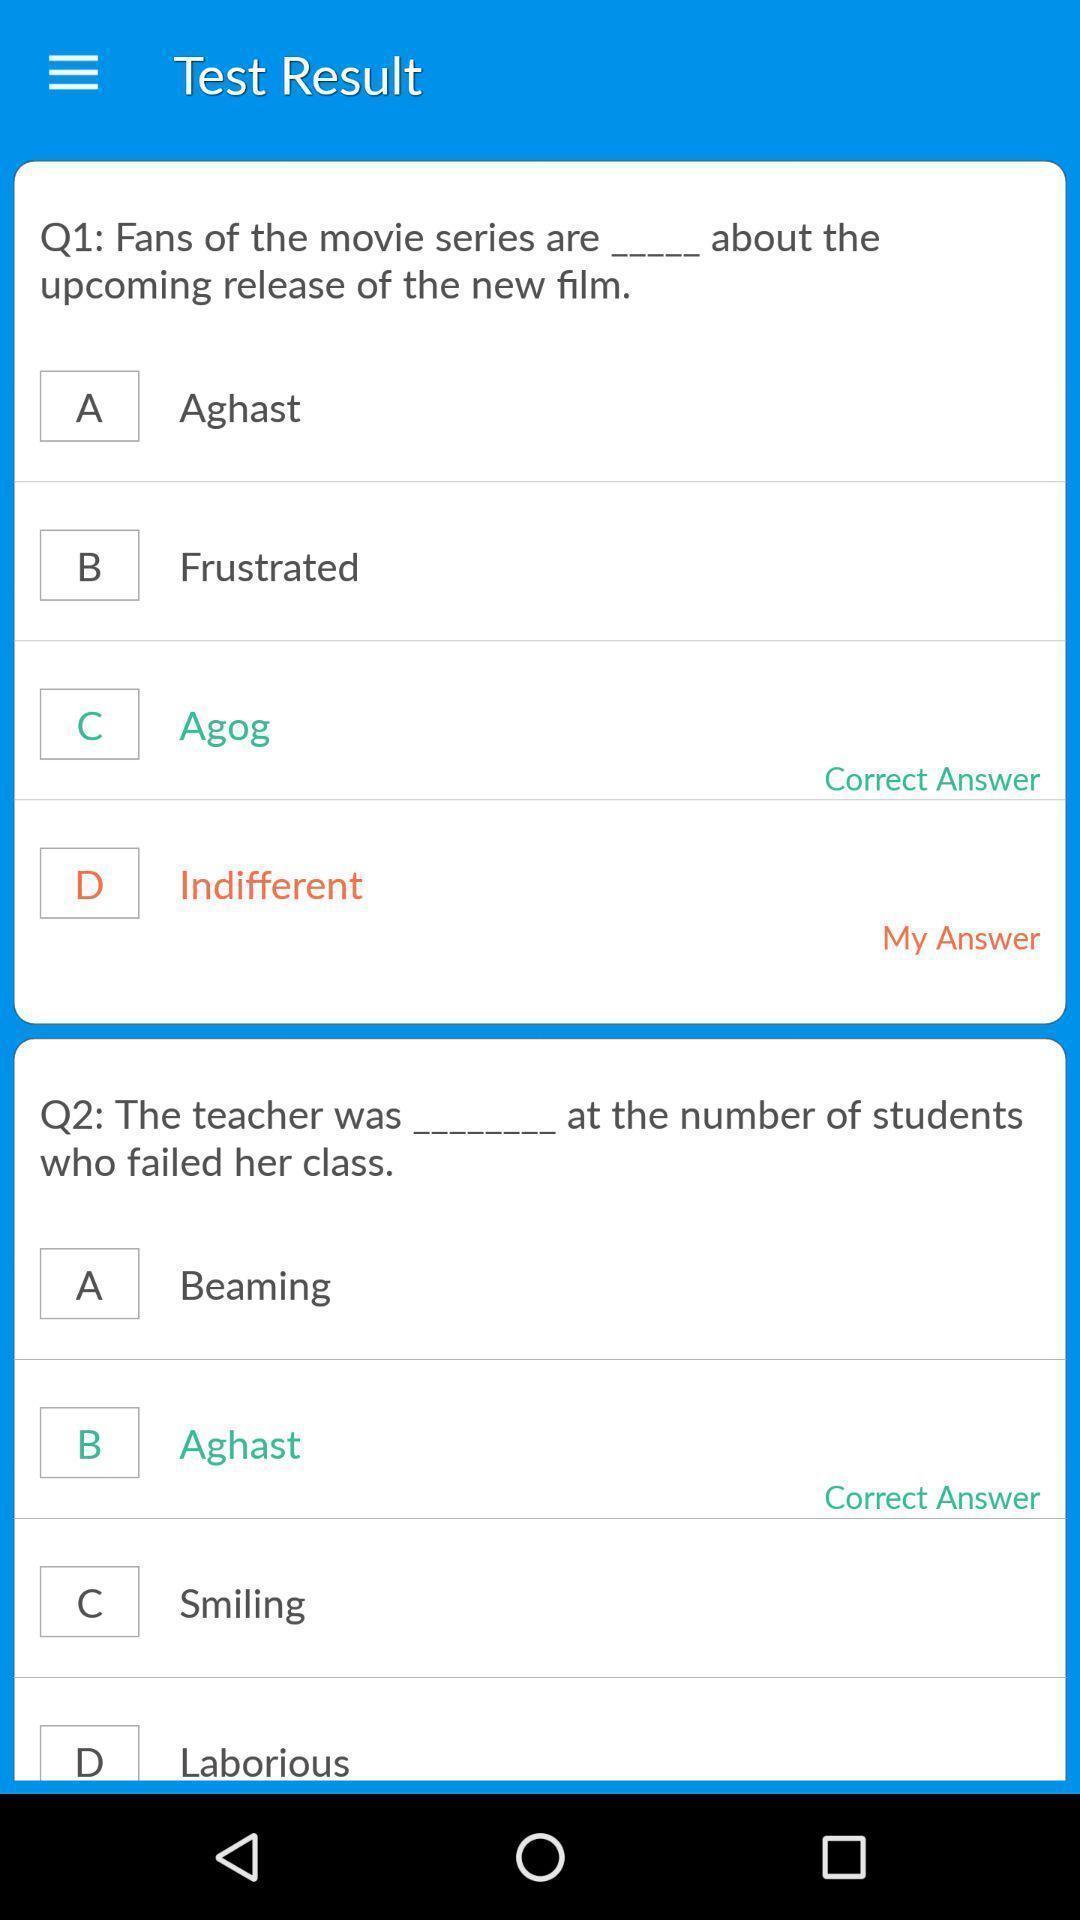Describe the content in this image. Screen displaying multiple questions of vocabulary learning app. 